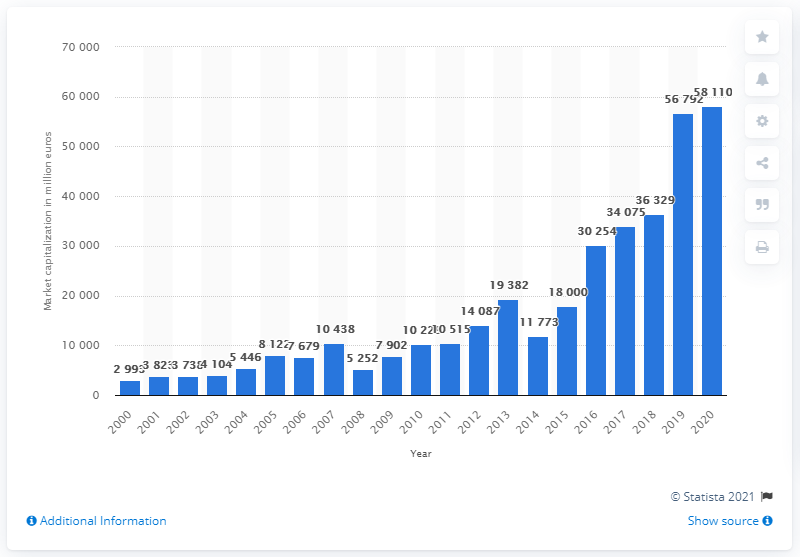Highlight a few significant elements in this photo. In 2000, the market capitalization of the Adidas Group was 2,993. In 2020, the market capitalization of the adidas Group was 58,110. 